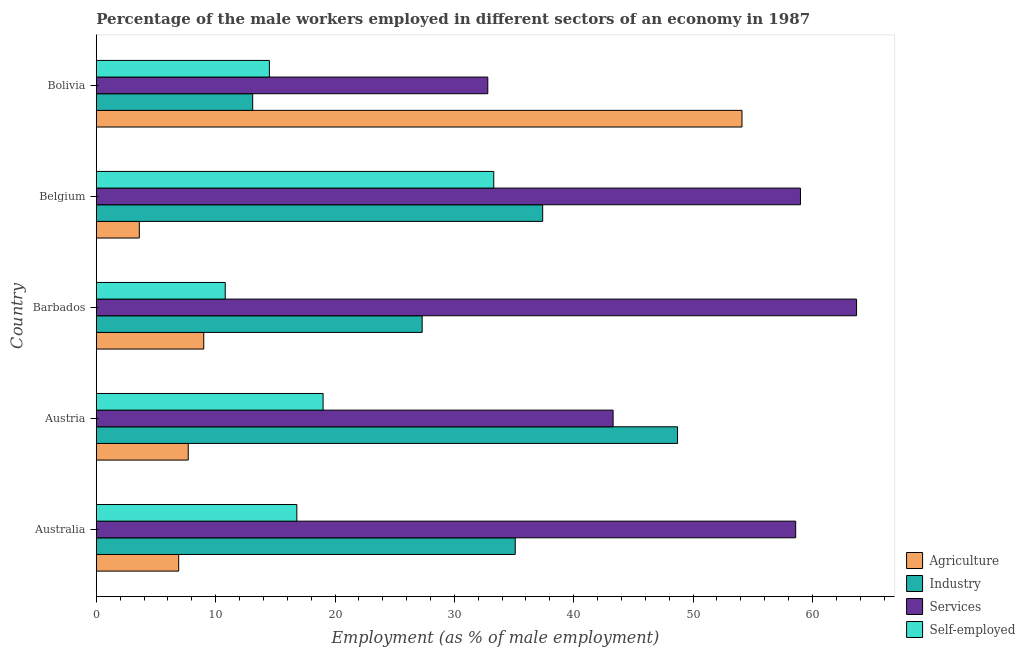How many different coloured bars are there?
Offer a very short reply. 4. How many bars are there on the 4th tick from the top?
Your answer should be very brief. 4. How many bars are there on the 3rd tick from the bottom?
Provide a succinct answer. 4. What is the label of the 1st group of bars from the top?
Make the answer very short. Bolivia. What is the percentage of self employed male workers in Barbados?
Make the answer very short. 10.8. Across all countries, what is the maximum percentage of male workers in industry?
Your answer should be compact. 48.7. Across all countries, what is the minimum percentage of male workers in industry?
Your response must be concise. 13.1. In which country was the percentage of male workers in services maximum?
Provide a short and direct response. Barbados. In which country was the percentage of male workers in agriculture minimum?
Give a very brief answer. Belgium. What is the total percentage of male workers in industry in the graph?
Ensure brevity in your answer.  161.6. What is the difference between the percentage of male workers in industry in Austria and that in Barbados?
Ensure brevity in your answer.  21.4. What is the difference between the percentage of male workers in services in Australia and the percentage of self employed male workers in Austria?
Make the answer very short. 39.6. What is the average percentage of self employed male workers per country?
Offer a very short reply. 18.88. What is the difference between the percentage of male workers in agriculture and percentage of male workers in services in Bolivia?
Your answer should be compact. 21.3. In how many countries, is the percentage of male workers in agriculture greater than 12 %?
Ensure brevity in your answer.  1. What is the ratio of the percentage of male workers in services in Australia to that in Belgium?
Keep it short and to the point. 0.99. Is the percentage of male workers in agriculture in Barbados less than that in Bolivia?
Offer a terse response. Yes. Is the difference between the percentage of self employed male workers in Belgium and Bolivia greater than the difference between the percentage of male workers in agriculture in Belgium and Bolivia?
Provide a short and direct response. Yes. What is the difference between the highest and the lowest percentage of male workers in agriculture?
Your answer should be compact. 50.5. In how many countries, is the percentage of self employed male workers greater than the average percentage of self employed male workers taken over all countries?
Offer a very short reply. 2. Is the sum of the percentage of male workers in services in Austria and Belgium greater than the maximum percentage of male workers in agriculture across all countries?
Offer a very short reply. Yes. Is it the case that in every country, the sum of the percentage of self employed male workers and percentage of male workers in services is greater than the sum of percentage of male workers in agriculture and percentage of male workers in industry?
Offer a very short reply. No. What does the 3rd bar from the top in Belgium represents?
Ensure brevity in your answer.  Industry. What does the 1st bar from the bottom in Barbados represents?
Give a very brief answer. Agriculture. How many bars are there?
Make the answer very short. 20. Are all the bars in the graph horizontal?
Offer a very short reply. Yes. How many countries are there in the graph?
Provide a short and direct response. 5. Does the graph contain grids?
Your response must be concise. No. Where does the legend appear in the graph?
Offer a very short reply. Bottom right. How are the legend labels stacked?
Provide a succinct answer. Vertical. What is the title of the graph?
Make the answer very short. Percentage of the male workers employed in different sectors of an economy in 1987. Does "Portugal" appear as one of the legend labels in the graph?
Offer a terse response. No. What is the label or title of the X-axis?
Ensure brevity in your answer.  Employment (as % of male employment). What is the Employment (as % of male employment) of Agriculture in Australia?
Offer a terse response. 6.9. What is the Employment (as % of male employment) in Industry in Australia?
Keep it short and to the point. 35.1. What is the Employment (as % of male employment) of Services in Australia?
Give a very brief answer. 58.6. What is the Employment (as % of male employment) in Self-employed in Australia?
Provide a short and direct response. 16.8. What is the Employment (as % of male employment) of Agriculture in Austria?
Your answer should be very brief. 7.7. What is the Employment (as % of male employment) in Industry in Austria?
Give a very brief answer. 48.7. What is the Employment (as % of male employment) in Services in Austria?
Your response must be concise. 43.3. What is the Employment (as % of male employment) in Self-employed in Austria?
Provide a succinct answer. 19. What is the Employment (as % of male employment) in Industry in Barbados?
Your answer should be compact. 27.3. What is the Employment (as % of male employment) in Services in Barbados?
Keep it short and to the point. 63.7. What is the Employment (as % of male employment) in Self-employed in Barbados?
Ensure brevity in your answer.  10.8. What is the Employment (as % of male employment) in Agriculture in Belgium?
Make the answer very short. 3.6. What is the Employment (as % of male employment) in Industry in Belgium?
Offer a terse response. 37.4. What is the Employment (as % of male employment) in Self-employed in Belgium?
Provide a short and direct response. 33.3. What is the Employment (as % of male employment) of Agriculture in Bolivia?
Offer a terse response. 54.1. What is the Employment (as % of male employment) of Industry in Bolivia?
Make the answer very short. 13.1. What is the Employment (as % of male employment) in Services in Bolivia?
Ensure brevity in your answer.  32.8. What is the Employment (as % of male employment) in Self-employed in Bolivia?
Make the answer very short. 14.5. Across all countries, what is the maximum Employment (as % of male employment) of Agriculture?
Ensure brevity in your answer.  54.1. Across all countries, what is the maximum Employment (as % of male employment) in Industry?
Provide a short and direct response. 48.7. Across all countries, what is the maximum Employment (as % of male employment) of Services?
Make the answer very short. 63.7. Across all countries, what is the maximum Employment (as % of male employment) of Self-employed?
Your answer should be compact. 33.3. Across all countries, what is the minimum Employment (as % of male employment) in Agriculture?
Provide a succinct answer. 3.6. Across all countries, what is the minimum Employment (as % of male employment) of Industry?
Give a very brief answer. 13.1. Across all countries, what is the minimum Employment (as % of male employment) in Services?
Keep it short and to the point. 32.8. Across all countries, what is the minimum Employment (as % of male employment) in Self-employed?
Give a very brief answer. 10.8. What is the total Employment (as % of male employment) in Agriculture in the graph?
Give a very brief answer. 81.3. What is the total Employment (as % of male employment) of Industry in the graph?
Give a very brief answer. 161.6. What is the total Employment (as % of male employment) in Services in the graph?
Your answer should be very brief. 257.4. What is the total Employment (as % of male employment) in Self-employed in the graph?
Offer a terse response. 94.4. What is the difference between the Employment (as % of male employment) in Agriculture in Australia and that in Austria?
Your response must be concise. -0.8. What is the difference between the Employment (as % of male employment) in Services in Australia and that in Austria?
Offer a very short reply. 15.3. What is the difference between the Employment (as % of male employment) in Agriculture in Australia and that in Barbados?
Provide a succinct answer. -2.1. What is the difference between the Employment (as % of male employment) in Services in Australia and that in Barbados?
Provide a short and direct response. -5.1. What is the difference between the Employment (as % of male employment) in Agriculture in Australia and that in Belgium?
Provide a short and direct response. 3.3. What is the difference between the Employment (as % of male employment) in Industry in Australia and that in Belgium?
Offer a very short reply. -2.3. What is the difference between the Employment (as % of male employment) in Services in Australia and that in Belgium?
Keep it short and to the point. -0.4. What is the difference between the Employment (as % of male employment) in Self-employed in Australia and that in Belgium?
Provide a succinct answer. -16.5. What is the difference between the Employment (as % of male employment) in Agriculture in Australia and that in Bolivia?
Give a very brief answer. -47.2. What is the difference between the Employment (as % of male employment) in Industry in Australia and that in Bolivia?
Make the answer very short. 22. What is the difference between the Employment (as % of male employment) in Services in Australia and that in Bolivia?
Provide a succinct answer. 25.8. What is the difference between the Employment (as % of male employment) in Self-employed in Australia and that in Bolivia?
Give a very brief answer. 2.3. What is the difference between the Employment (as % of male employment) in Industry in Austria and that in Barbados?
Provide a short and direct response. 21.4. What is the difference between the Employment (as % of male employment) in Services in Austria and that in Barbados?
Your answer should be very brief. -20.4. What is the difference between the Employment (as % of male employment) in Industry in Austria and that in Belgium?
Offer a very short reply. 11.3. What is the difference between the Employment (as % of male employment) in Services in Austria and that in Belgium?
Provide a succinct answer. -15.7. What is the difference between the Employment (as % of male employment) in Self-employed in Austria and that in Belgium?
Your answer should be very brief. -14.3. What is the difference between the Employment (as % of male employment) in Agriculture in Austria and that in Bolivia?
Make the answer very short. -46.4. What is the difference between the Employment (as % of male employment) of Industry in Austria and that in Bolivia?
Keep it short and to the point. 35.6. What is the difference between the Employment (as % of male employment) in Services in Austria and that in Bolivia?
Your answer should be compact. 10.5. What is the difference between the Employment (as % of male employment) in Self-employed in Austria and that in Bolivia?
Offer a terse response. 4.5. What is the difference between the Employment (as % of male employment) of Agriculture in Barbados and that in Belgium?
Offer a very short reply. 5.4. What is the difference between the Employment (as % of male employment) in Services in Barbados and that in Belgium?
Offer a terse response. 4.7. What is the difference between the Employment (as % of male employment) of Self-employed in Barbados and that in Belgium?
Make the answer very short. -22.5. What is the difference between the Employment (as % of male employment) of Agriculture in Barbados and that in Bolivia?
Offer a very short reply. -45.1. What is the difference between the Employment (as % of male employment) in Industry in Barbados and that in Bolivia?
Offer a terse response. 14.2. What is the difference between the Employment (as % of male employment) in Services in Barbados and that in Bolivia?
Offer a terse response. 30.9. What is the difference between the Employment (as % of male employment) in Self-employed in Barbados and that in Bolivia?
Give a very brief answer. -3.7. What is the difference between the Employment (as % of male employment) of Agriculture in Belgium and that in Bolivia?
Offer a terse response. -50.5. What is the difference between the Employment (as % of male employment) of Industry in Belgium and that in Bolivia?
Your answer should be compact. 24.3. What is the difference between the Employment (as % of male employment) in Services in Belgium and that in Bolivia?
Your response must be concise. 26.2. What is the difference between the Employment (as % of male employment) of Agriculture in Australia and the Employment (as % of male employment) of Industry in Austria?
Provide a short and direct response. -41.8. What is the difference between the Employment (as % of male employment) of Agriculture in Australia and the Employment (as % of male employment) of Services in Austria?
Provide a short and direct response. -36.4. What is the difference between the Employment (as % of male employment) in Industry in Australia and the Employment (as % of male employment) in Services in Austria?
Make the answer very short. -8.2. What is the difference between the Employment (as % of male employment) of Services in Australia and the Employment (as % of male employment) of Self-employed in Austria?
Your answer should be compact. 39.6. What is the difference between the Employment (as % of male employment) of Agriculture in Australia and the Employment (as % of male employment) of Industry in Barbados?
Provide a succinct answer. -20.4. What is the difference between the Employment (as % of male employment) in Agriculture in Australia and the Employment (as % of male employment) in Services in Barbados?
Offer a very short reply. -56.8. What is the difference between the Employment (as % of male employment) of Agriculture in Australia and the Employment (as % of male employment) of Self-employed in Barbados?
Make the answer very short. -3.9. What is the difference between the Employment (as % of male employment) of Industry in Australia and the Employment (as % of male employment) of Services in Barbados?
Your response must be concise. -28.6. What is the difference between the Employment (as % of male employment) in Industry in Australia and the Employment (as % of male employment) in Self-employed in Barbados?
Your answer should be very brief. 24.3. What is the difference between the Employment (as % of male employment) in Services in Australia and the Employment (as % of male employment) in Self-employed in Barbados?
Give a very brief answer. 47.8. What is the difference between the Employment (as % of male employment) of Agriculture in Australia and the Employment (as % of male employment) of Industry in Belgium?
Make the answer very short. -30.5. What is the difference between the Employment (as % of male employment) in Agriculture in Australia and the Employment (as % of male employment) in Services in Belgium?
Give a very brief answer. -52.1. What is the difference between the Employment (as % of male employment) in Agriculture in Australia and the Employment (as % of male employment) in Self-employed in Belgium?
Provide a short and direct response. -26.4. What is the difference between the Employment (as % of male employment) in Industry in Australia and the Employment (as % of male employment) in Services in Belgium?
Offer a terse response. -23.9. What is the difference between the Employment (as % of male employment) of Services in Australia and the Employment (as % of male employment) of Self-employed in Belgium?
Ensure brevity in your answer.  25.3. What is the difference between the Employment (as % of male employment) of Agriculture in Australia and the Employment (as % of male employment) of Services in Bolivia?
Your answer should be very brief. -25.9. What is the difference between the Employment (as % of male employment) of Agriculture in Australia and the Employment (as % of male employment) of Self-employed in Bolivia?
Make the answer very short. -7.6. What is the difference between the Employment (as % of male employment) in Industry in Australia and the Employment (as % of male employment) in Self-employed in Bolivia?
Your answer should be very brief. 20.6. What is the difference between the Employment (as % of male employment) of Services in Australia and the Employment (as % of male employment) of Self-employed in Bolivia?
Your answer should be very brief. 44.1. What is the difference between the Employment (as % of male employment) in Agriculture in Austria and the Employment (as % of male employment) in Industry in Barbados?
Ensure brevity in your answer.  -19.6. What is the difference between the Employment (as % of male employment) in Agriculture in Austria and the Employment (as % of male employment) in Services in Barbados?
Make the answer very short. -56. What is the difference between the Employment (as % of male employment) in Agriculture in Austria and the Employment (as % of male employment) in Self-employed in Barbados?
Offer a terse response. -3.1. What is the difference between the Employment (as % of male employment) of Industry in Austria and the Employment (as % of male employment) of Services in Barbados?
Your response must be concise. -15. What is the difference between the Employment (as % of male employment) of Industry in Austria and the Employment (as % of male employment) of Self-employed in Barbados?
Offer a very short reply. 37.9. What is the difference between the Employment (as % of male employment) in Services in Austria and the Employment (as % of male employment) in Self-employed in Barbados?
Provide a short and direct response. 32.5. What is the difference between the Employment (as % of male employment) of Agriculture in Austria and the Employment (as % of male employment) of Industry in Belgium?
Offer a terse response. -29.7. What is the difference between the Employment (as % of male employment) in Agriculture in Austria and the Employment (as % of male employment) in Services in Belgium?
Ensure brevity in your answer.  -51.3. What is the difference between the Employment (as % of male employment) in Agriculture in Austria and the Employment (as % of male employment) in Self-employed in Belgium?
Provide a short and direct response. -25.6. What is the difference between the Employment (as % of male employment) of Services in Austria and the Employment (as % of male employment) of Self-employed in Belgium?
Offer a terse response. 10. What is the difference between the Employment (as % of male employment) in Agriculture in Austria and the Employment (as % of male employment) in Industry in Bolivia?
Ensure brevity in your answer.  -5.4. What is the difference between the Employment (as % of male employment) in Agriculture in Austria and the Employment (as % of male employment) in Services in Bolivia?
Make the answer very short. -25.1. What is the difference between the Employment (as % of male employment) of Industry in Austria and the Employment (as % of male employment) of Self-employed in Bolivia?
Ensure brevity in your answer.  34.2. What is the difference between the Employment (as % of male employment) of Services in Austria and the Employment (as % of male employment) of Self-employed in Bolivia?
Your response must be concise. 28.8. What is the difference between the Employment (as % of male employment) of Agriculture in Barbados and the Employment (as % of male employment) of Industry in Belgium?
Provide a short and direct response. -28.4. What is the difference between the Employment (as % of male employment) in Agriculture in Barbados and the Employment (as % of male employment) in Self-employed in Belgium?
Offer a terse response. -24.3. What is the difference between the Employment (as % of male employment) of Industry in Barbados and the Employment (as % of male employment) of Services in Belgium?
Your answer should be very brief. -31.7. What is the difference between the Employment (as % of male employment) in Industry in Barbados and the Employment (as % of male employment) in Self-employed in Belgium?
Your response must be concise. -6. What is the difference between the Employment (as % of male employment) in Services in Barbados and the Employment (as % of male employment) in Self-employed in Belgium?
Provide a short and direct response. 30.4. What is the difference between the Employment (as % of male employment) in Agriculture in Barbados and the Employment (as % of male employment) in Services in Bolivia?
Your response must be concise. -23.8. What is the difference between the Employment (as % of male employment) of Industry in Barbados and the Employment (as % of male employment) of Self-employed in Bolivia?
Provide a succinct answer. 12.8. What is the difference between the Employment (as % of male employment) of Services in Barbados and the Employment (as % of male employment) of Self-employed in Bolivia?
Make the answer very short. 49.2. What is the difference between the Employment (as % of male employment) of Agriculture in Belgium and the Employment (as % of male employment) of Industry in Bolivia?
Your response must be concise. -9.5. What is the difference between the Employment (as % of male employment) in Agriculture in Belgium and the Employment (as % of male employment) in Services in Bolivia?
Provide a succinct answer. -29.2. What is the difference between the Employment (as % of male employment) in Industry in Belgium and the Employment (as % of male employment) in Services in Bolivia?
Provide a succinct answer. 4.6. What is the difference between the Employment (as % of male employment) in Industry in Belgium and the Employment (as % of male employment) in Self-employed in Bolivia?
Provide a succinct answer. 22.9. What is the difference between the Employment (as % of male employment) of Services in Belgium and the Employment (as % of male employment) of Self-employed in Bolivia?
Provide a succinct answer. 44.5. What is the average Employment (as % of male employment) of Agriculture per country?
Offer a terse response. 16.26. What is the average Employment (as % of male employment) of Industry per country?
Give a very brief answer. 32.32. What is the average Employment (as % of male employment) in Services per country?
Your response must be concise. 51.48. What is the average Employment (as % of male employment) in Self-employed per country?
Offer a terse response. 18.88. What is the difference between the Employment (as % of male employment) in Agriculture and Employment (as % of male employment) in Industry in Australia?
Ensure brevity in your answer.  -28.2. What is the difference between the Employment (as % of male employment) of Agriculture and Employment (as % of male employment) of Services in Australia?
Your answer should be very brief. -51.7. What is the difference between the Employment (as % of male employment) of Agriculture and Employment (as % of male employment) of Self-employed in Australia?
Offer a terse response. -9.9. What is the difference between the Employment (as % of male employment) of Industry and Employment (as % of male employment) of Services in Australia?
Ensure brevity in your answer.  -23.5. What is the difference between the Employment (as % of male employment) in Industry and Employment (as % of male employment) in Self-employed in Australia?
Your answer should be very brief. 18.3. What is the difference between the Employment (as % of male employment) in Services and Employment (as % of male employment) in Self-employed in Australia?
Provide a succinct answer. 41.8. What is the difference between the Employment (as % of male employment) in Agriculture and Employment (as % of male employment) in Industry in Austria?
Your response must be concise. -41. What is the difference between the Employment (as % of male employment) of Agriculture and Employment (as % of male employment) of Services in Austria?
Your answer should be compact. -35.6. What is the difference between the Employment (as % of male employment) in Agriculture and Employment (as % of male employment) in Self-employed in Austria?
Give a very brief answer. -11.3. What is the difference between the Employment (as % of male employment) of Industry and Employment (as % of male employment) of Services in Austria?
Your answer should be very brief. 5.4. What is the difference between the Employment (as % of male employment) in Industry and Employment (as % of male employment) in Self-employed in Austria?
Your response must be concise. 29.7. What is the difference between the Employment (as % of male employment) in Services and Employment (as % of male employment) in Self-employed in Austria?
Offer a very short reply. 24.3. What is the difference between the Employment (as % of male employment) in Agriculture and Employment (as % of male employment) in Industry in Barbados?
Offer a terse response. -18.3. What is the difference between the Employment (as % of male employment) of Agriculture and Employment (as % of male employment) of Services in Barbados?
Provide a succinct answer. -54.7. What is the difference between the Employment (as % of male employment) in Agriculture and Employment (as % of male employment) in Self-employed in Barbados?
Your answer should be very brief. -1.8. What is the difference between the Employment (as % of male employment) of Industry and Employment (as % of male employment) of Services in Barbados?
Your answer should be very brief. -36.4. What is the difference between the Employment (as % of male employment) of Industry and Employment (as % of male employment) of Self-employed in Barbados?
Give a very brief answer. 16.5. What is the difference between the Employment (as % of male employment) of Services and Employment (as % of male employment) of Self-employed in Barbados?
Your answer should be very brief. 52.9. What is the difference between the Employment (as % of male employment) of Agriculture and Employment (as % of male employment) of Industry in Belgium?
Offer a very short reply. -33.8. What is the difference between the Employment (as % of male employment) in Agriculture and Employment (as % of male employment) in Services in Belgium?
Offer a terse response. -55.4. What is the difference between the Employment (as % of male employment) of Agriculture and Employment (as % of male employment) of Self-employed in Belgium?
Offer a very short reply. -29.7. What is the difference between the Employment (as % of male employment) of Industry and Employment (as % of male employment) of Services in Belgium?
Ensure brevity in your answer.  -21.6. What is the difference between the Employment (as % of male employment) of Services and Employment (as % of male employment) of Self-employed in Belgium?
Your answer should be compact. 25.7. What is the difference between the Employment (as % of male employment) of Agriculture and Employment (as % of male employment) of Services in Bolivia?
Offer a terse response. 21.3. What is the difference between the Employment (as % of male employment) in Agriculture and Employment (as % of male employment) in Self-employed in Bolivia?
Your answer should be compact. 39.6. What is the difference between the Employment (as % of male employment) of Industry and Employment (as % of male employment) of Services in Bolivia?
Make the answer very short. -19.7. What is the difference between the Employment (as % of male employment) in Industry and Employment (as % of male employment) in Self-employed in Bolivia?
Provide a short and direct response. -1.4. What is the ratio of the Employment (as % of male employment) in Agriculture in Australia to that in Austria?
Make the answer very short. 0.9. What is the ratio of the Employment (as % of male employment) in Industry in Australia to that in Austria?
Give a very brief answer. 0.72. What is the ratio of the Employment (as % of male employment) of Services in Australia to that in Austria?
Keep it short and to the point. 1.35. What is the ratio of the Employment (as % of male employment) of Self-employed in Australia to that in Austria?
Keep it short and to the point. 0.88. What is the ratio of the Employment (as % of male employment) in Agriculture in Australia to that in Barbados?
Your answer should be very brief. 0.77. What is the ratio of the Employment (as % of male employment) in Services in Australia to that in Barbados?
Your answer should be compact. 0.92. What is the ratio of the Employment (as % of male employment) in Self-employed in Australia to that in Barbados?
Your response must be concise. 1.56. What is the ratio of the Employment (as % of male employment) of Agriculture in Australia to that in Belgium?
Your answer should be very brief. 1.92. What is the ratio of the Employment (as % of male employment) in Industry in Australia to that in Belgium?
Offer a very short reply. 0.94. What is the ratio of the Employment (as % of male employment) in Self-employed in Australia to that in Belgium?
Provide a succinct answer. 0.5. What is the ratio of the Employment (as % of male employment) in Agriculture in Australia to that in Bolivia?
Keep it short and to the point. 0.13. What is the ratio of the Employment (as % of male employment) of Industry in Australia to that in Bolivia?
Make the answer very short. 2.68. What is the ratio of the Employment (as % of male employment) in Services in Australia to that in Bolivia?
Provide a succinct answer. 1.79. What is the ratio of the Employment (as % of male employment) in Self-employed in Australia to that in Bolivia?
Your response must be concise. 1.16. What is the ratio of the Employment (as % of male employment) of Agriculture in Austria to that in Barbados?
Provide a short and direct response. 0.86. What is the ratio of the Employment (as % of male employment) of Industry in Austria to that in Barbados?
Offer a terse response. 1.78. What is the ratio of the Employment (as % of male employment) of Services in Austria to that in Barbados?
Your answer should be very brief. 0.68. What is the ratio of the Employment (as % of male employment) in Self-employed in Austria to that in Barbados?
Provide a short and direct response. 1.76. What is the ratio of the Employment (as % of male employment) in Agriculture in Austria to that in Belgium?
Your answer should be very brief. 2.14. What is the ratio of the Employment (as % of male employment) in Industry in Austria to that in Belgium?
Your response must be concise. 1.3. What is the ratio of the Employment (as % of male employment) in Services in Austria to that in Belgium?
Your answer should be compact. 0.73. What is the ratio of the Employment (as % of male employment) of Self-employed in Austria to that in Belgium?
Make the answer very short. 0.57. What is the ratio of the Employment (as % of male employment) of Agriculture in Austria to that in Bolivia?
Offer a terse response. 0.14. What is the ratio of the Employment (as % of male employment) of Industry in Austria to that in Bolivia?
Offer a very short reply. 3.72. What is the ratio of the Employment (as % of male employment) in Services in Austria to that in Bolivia?
Your answer should be very brief. 1.32. What is the ratio of the Employment (as % of male employment) of Self-employed in Austria to that in Bolivia?
Provide a succinct answer. 1.31. What is the ratio of the Employment (as % of male employment) in Industry in Barbados to that in Belgium?
Offer a terse response. 0.73. What is the ratio of the Employment (as % of male employment) of Services in Barbados to that in Belgium?
Offer a very short reply. 1.08. What is the ratio of the Employment (as % of male employment) in Self-employed in Barbados to that in Belgium?
Keep it short and to the point. 0.32. What is the ratio of the Employment (as % of male employment) in Agriculture in Barbados to that in Bolivia?
Ensure brevity in your answer.  0.17. What is the ratio of the Employment (as % of male employment) of Industry in Barbados to that in Bolivia?
Ensure brevity in your answer.  2.08. What is the ratio of the Employment (as % of male employment) of Services in Barbados to that in Bolivia?
Give a very brief answer. 1.94. What is the ratio of the Employment (as % of male employment) of Self-employed in Barbados to that in Bolivia?
Provide a succinct answer. 0.74. What is the ratio of the Employment (as % of male employment) of Agriculture in Belgium to that in Bolivia?
Provide a short and direct response. 0.07. What is the ratio of the Employment (as % of male employment) in Industry in Belgium to that in Bolivia?
Provide a short and direct response. 2.85. What is the ratio of the Employment (as % of male employment) in Services in Belgium to that in Bolivia?
Ensure brevity in your answer.  1.8. What is the ratio of the Employment (as % of male employment) in Self-employed in Belgium to that in Bolivia?
Keep it short and to the point. 2.3. What is the difference between the highest and the second highest Employment (as % of male employment) in Agriculture?
Make the answer very short. 45.1. What is the difference between the highest and the second highest Employment (as % of male employment) in Services?
Your response must be concise. 4.7. What is the difference between the highest and the second highest Employment (as % of male employment) of Self-employed?
Provide a succinct answer. 14.3. What is the difference between the highest and the lowest Employment (as % of male employment) of Agriculture?
Your response must be concise. 50.5. What is the difference between the highest and the lowest Employment (as % of male employment) of Industry?
Provide a succinct answer. 35.6. What is the difference between the highest and the lowest Employment (as % of male employment) of Services?
Offer a very short reply. 30.9. What is the difference between the highest and the lowest Employment (as % of male employment) of Self-employed?
Your response must be concise. 22.5. 